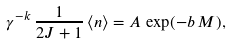Convert formula to latex. <formula><loc_0><loc_0><loc_500><loc_500>\gamma ^ { - k } \, \frac { 1 } { 2 J + 1 } \, { \langle n \rangle } = A \, \exp ( - b \, M ) ,</formula> 